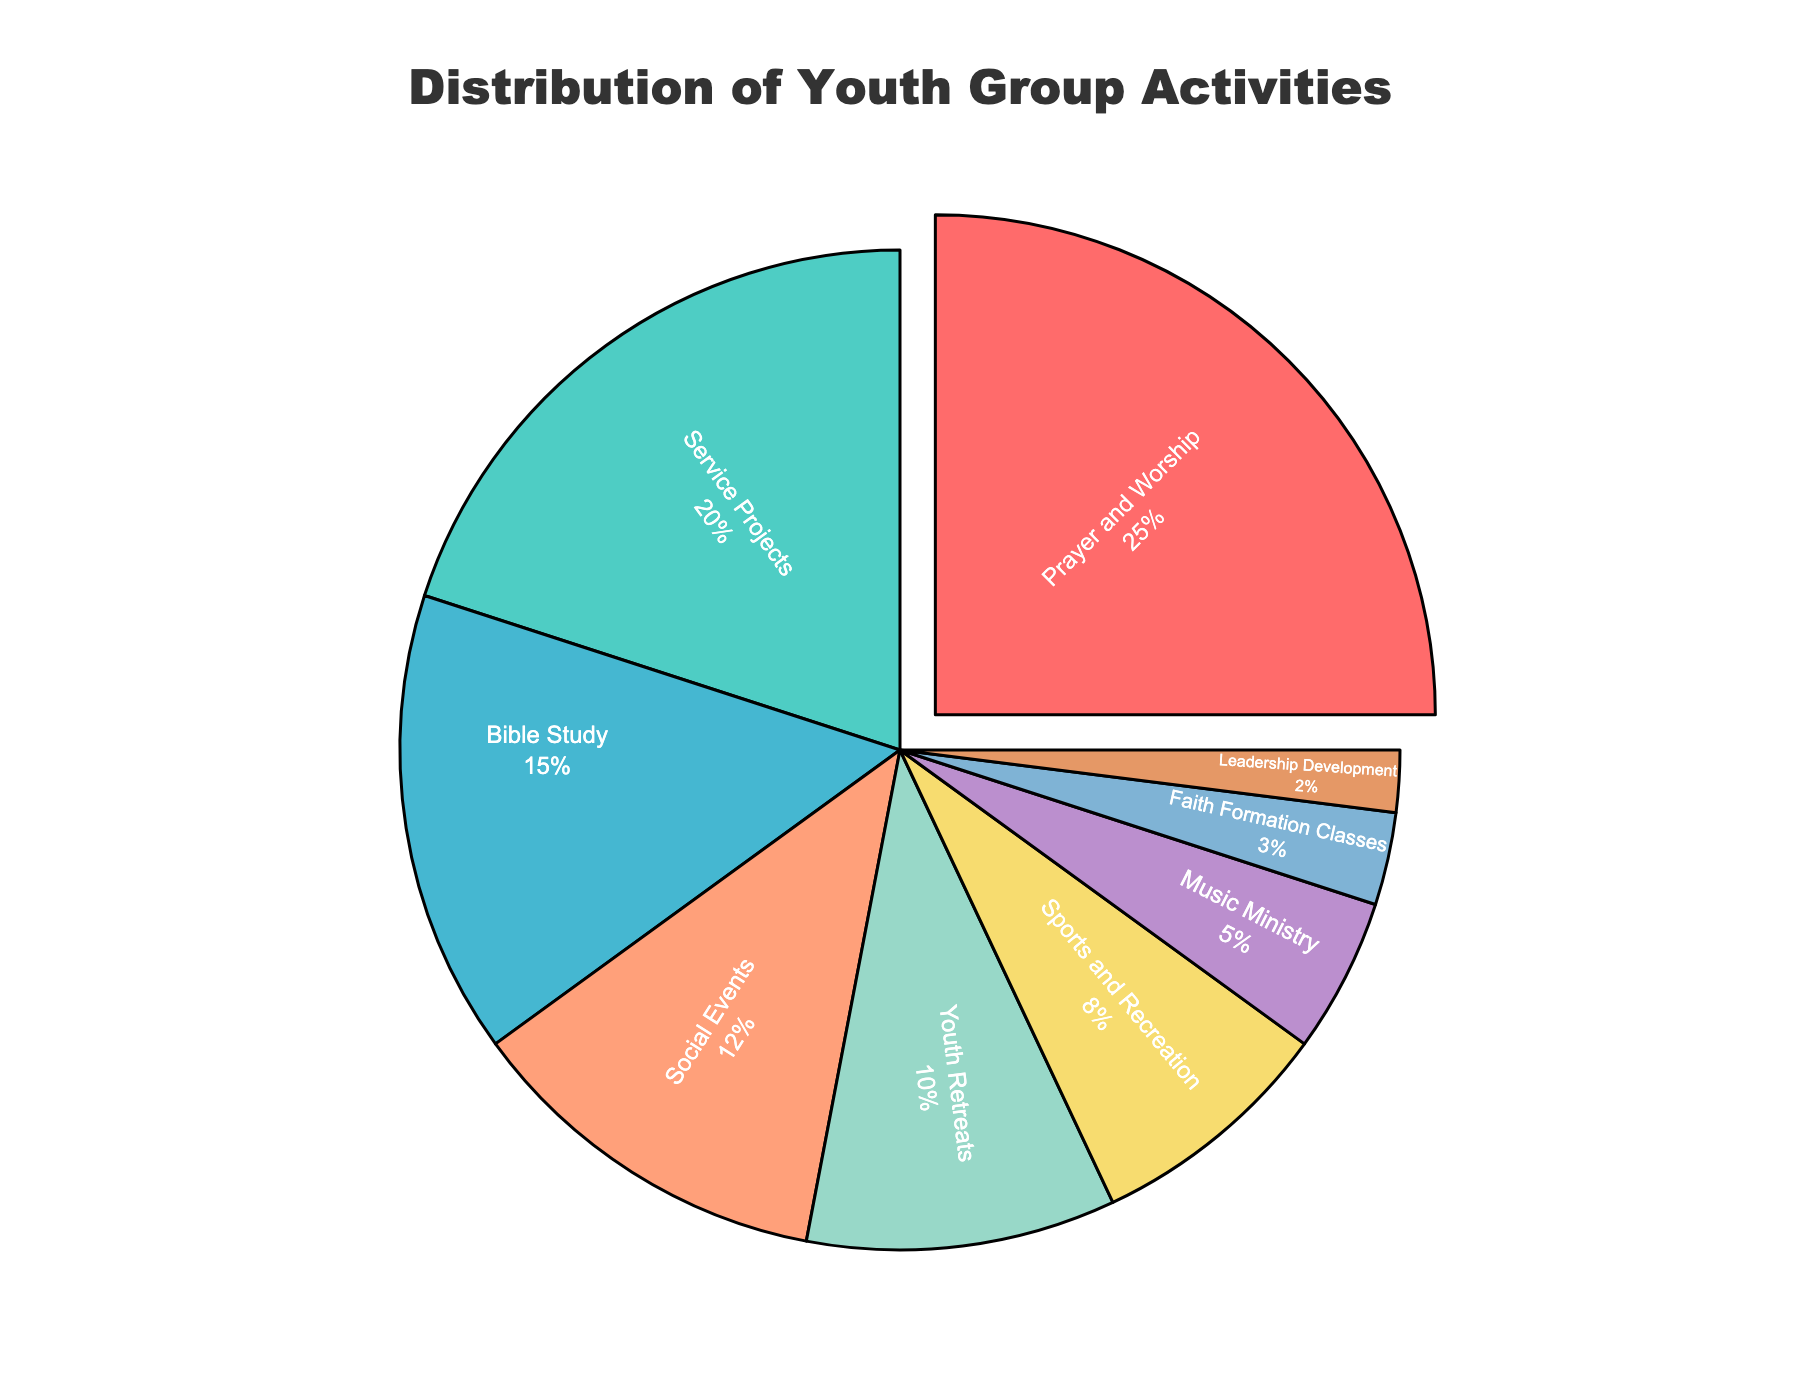Which category has the largest percentage of youth group activities? The figure shows that "Prayer and Worship" has the largest segment, indicating it has the highest percentage.
Answer: Prayer and Worship Which categories together make up more than 50% of youth group activities? Adding the percentages for "Prayer and Worship" (25%) and "Service Projects" (20%) gives us 45%. Including "Bible Study" (15%) brings the total to 60%, which is more than 50%.
Answer: Prayer and Worship, Service Projects, Bible Study What is the combined percentage of categories related to faith enhancement (Prayer and Worship, Bible Study, Faith Formation Classes)? Summing the percentages of "Prayer and Worship" (25%), "Bible Study" (15%), and "Faith Formation Classes" (3%) gives us 43%.
Answer: 43% Which category has the smallest percentage, and what is it? The figure shows "Leadership Development" with the smallest segment, which is 2%.
Answer: Leadership Development, 2% How do "Youth Retreats" and "Social Events" compare in terms of their percentage representation? "Youth Retreats" have 10% and "Social Events" have 12%. Thus, "Social Events" have a higher percentage by 2%.
Answer: Social Events have 2% more If we combine "Service Projects" and "Sports and Recreation," what percentage do they constitute? Adding "Service Projects" (20%) and "Sports and Recreation" (8%) gives a total of 28%.
Answer: 28% What is the difference in percentage between "Music Ministry" and "Faith Formation Classes"? "Music Ministry" has 5% and "Faith Formation Classes" has 3%. The difference is 5% - 3% = 2%.
Answer: 2% What percentage of youth group activities are non-religious (combining Social Events and Sports and Recreation)? Adding the percentages for "Social Events" (12%) and "Sports and Recreation" (8%) gives us 20%.
Answer: 20% How does the combined percentage of "Music Ministry" and "Leadership Development" compare to "Youth Retreats"? Summing "Music Ministry" (5%) and "Leadership Development" (2%) gives us 7%, which is 3% less than "Youth Retreats" which has 10%.
Answer: 3% less Which visual attribute stands out for the category with the largest percentage? The figure shows that the "Prayer and Worship" segment is pulled out slightly, making it visually prominent.
Answer: Segment is pulled out slightly 